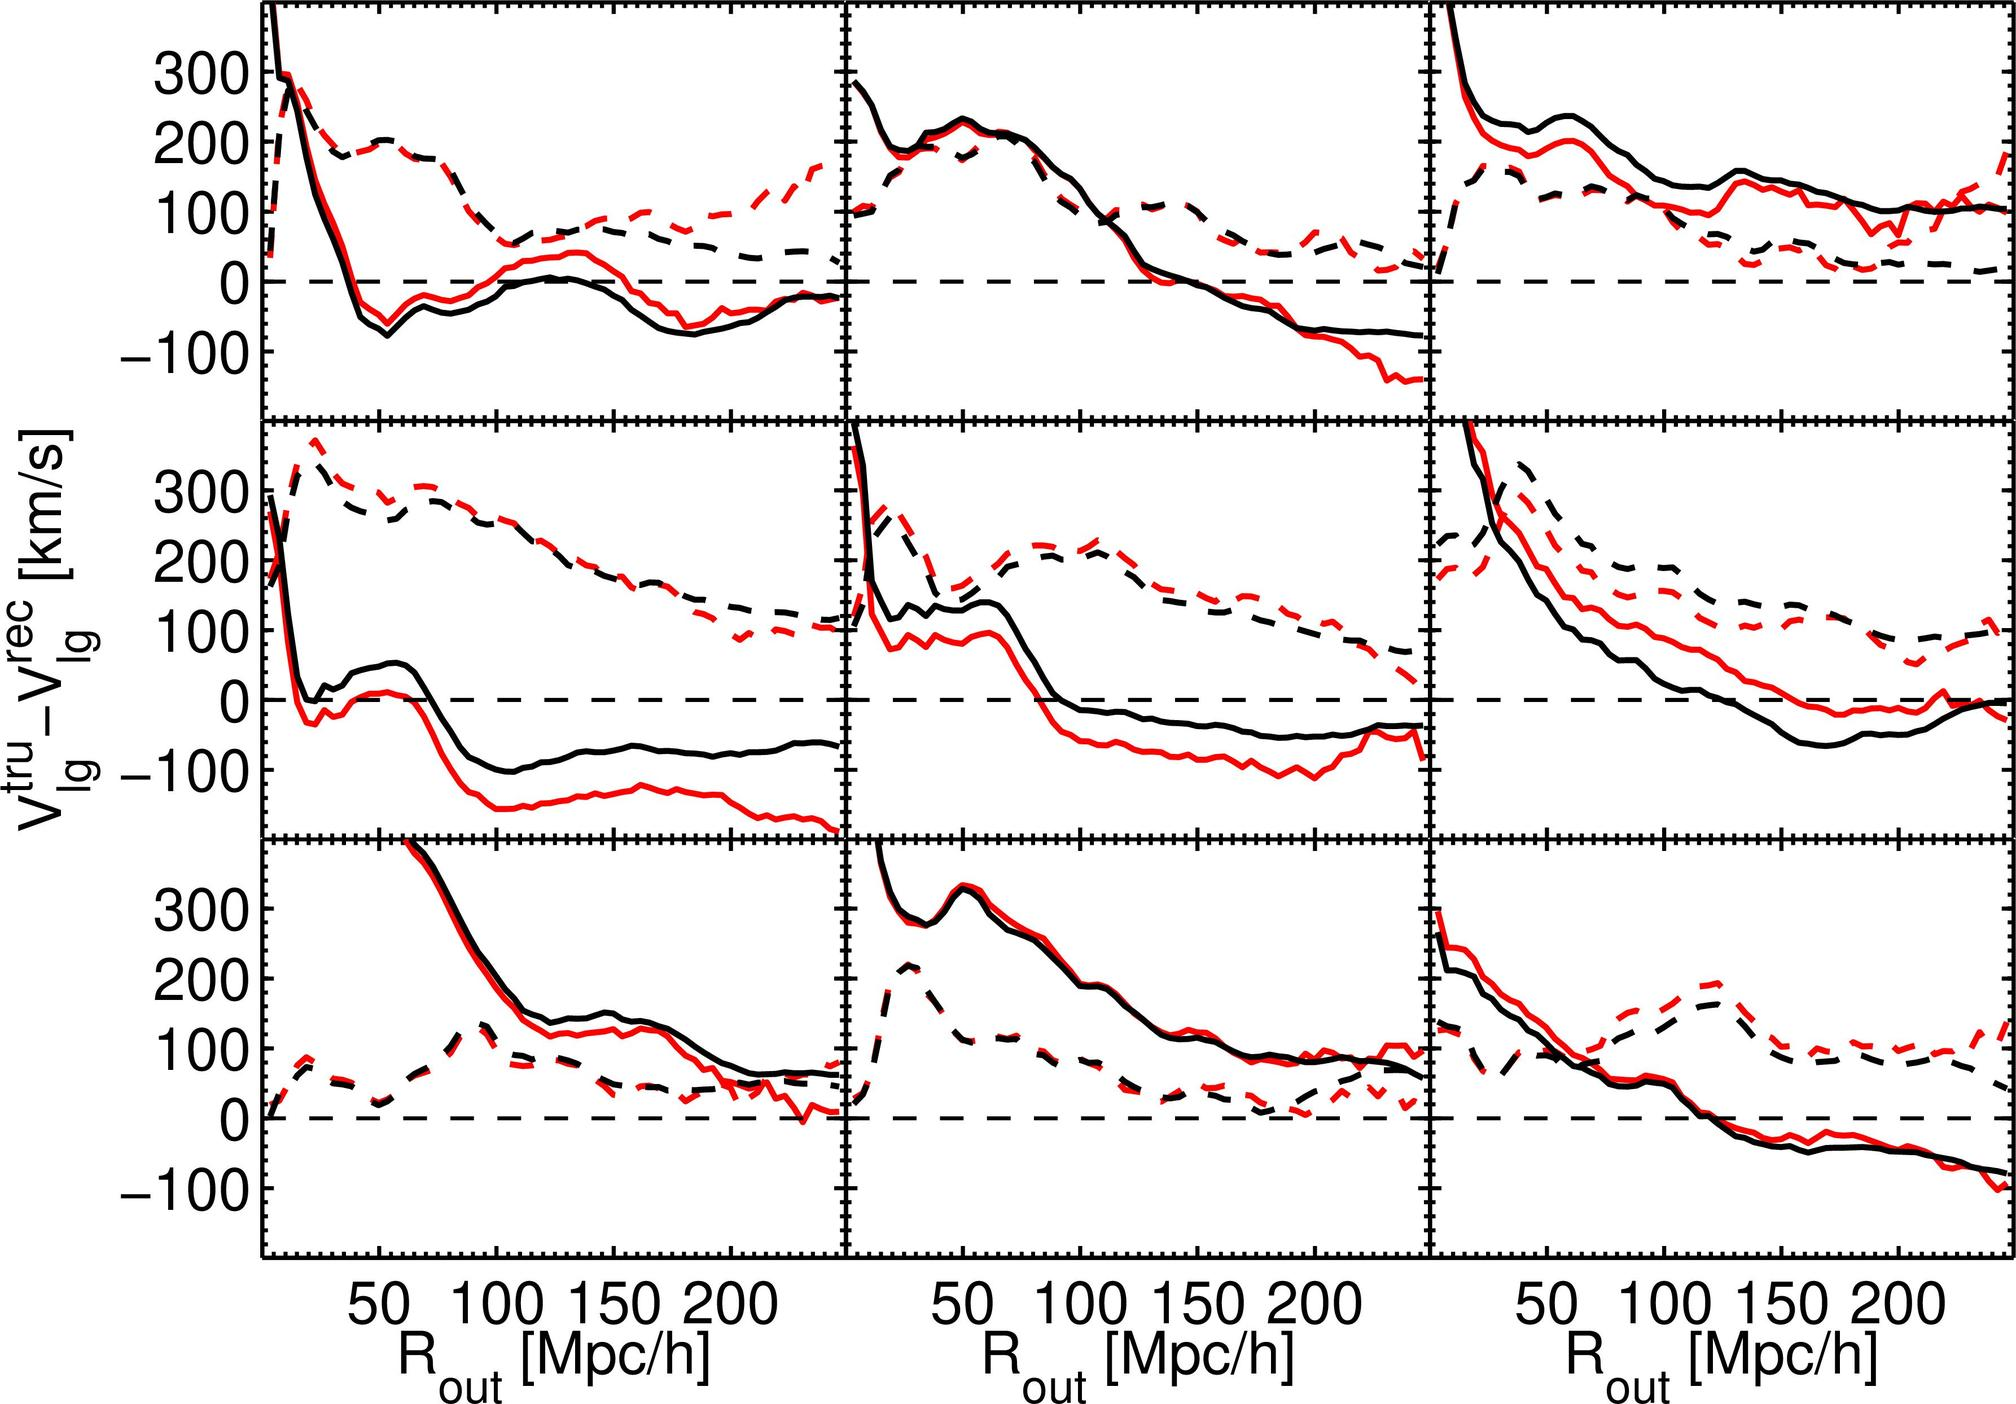Can you describe the significance of these velocity differences in the plots? The velocity differences plotted here indicate how galaxies are moving relative to each other and the theoretical baseline (dashed line). Such differences can reveal critical information about the dynamics of the universe, like how galaxies cluster, how they're influenced by dark matter, and potential insights into cosmic expansion and gravitational effects. 